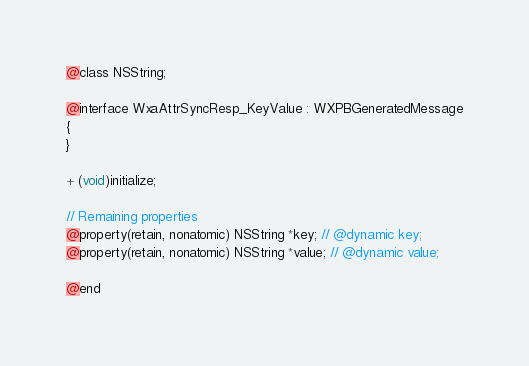Convert code to text. <code><loc_0><loc_0><loc_500><loc_500><_C_>@class NSString;

@interface WxaAttrSyncResp_KeyValue : WXPBGeneratedMessage
{
}

+ (void)initialize;

// Remaining properties
@property(retain, nonatomic) NSString *key; // @dynamic key;
@property(retain, nonatomic) NSString *value; // @dynamic value;

@end

</code> 